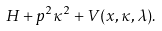Convert formula to latex. <formula><loc_0><loc_0><loc_500><loc_500>H + p ^ { 2 } \kappa ^ { 2 } + V ( x , \kappa , \lambda ) .</formula> 